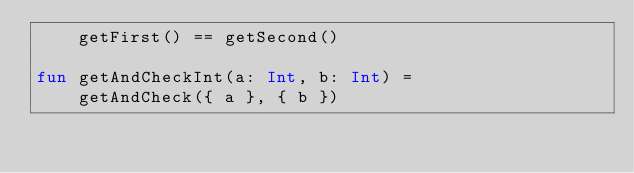Convert code to text. <code><loc_0><loc_0><loc_500><loc_500><_Kotlin_>    getFirst() == getSecond()

fun getAndCheckInt(a: Int, b: Int) =
    getAndCheck({ a }, { b })
</code> 